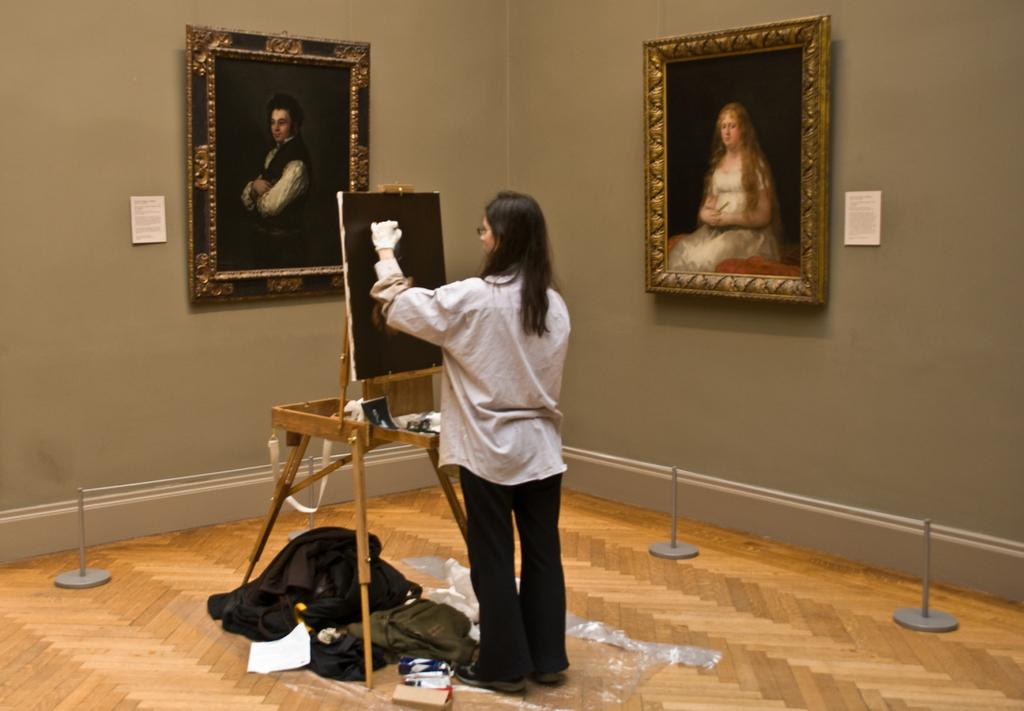What is the person in the image doing? The person is painting on a board. What can be seen on the ground in the image? There are objects on the ground. What is behind the person in the image? There is a wall behind the person. What is hanging on the wall in the image? There are photo frames and papers on the wall. Can you see a pencil being used to draw a duck in the image? There is no pencil or duck present in the image. 